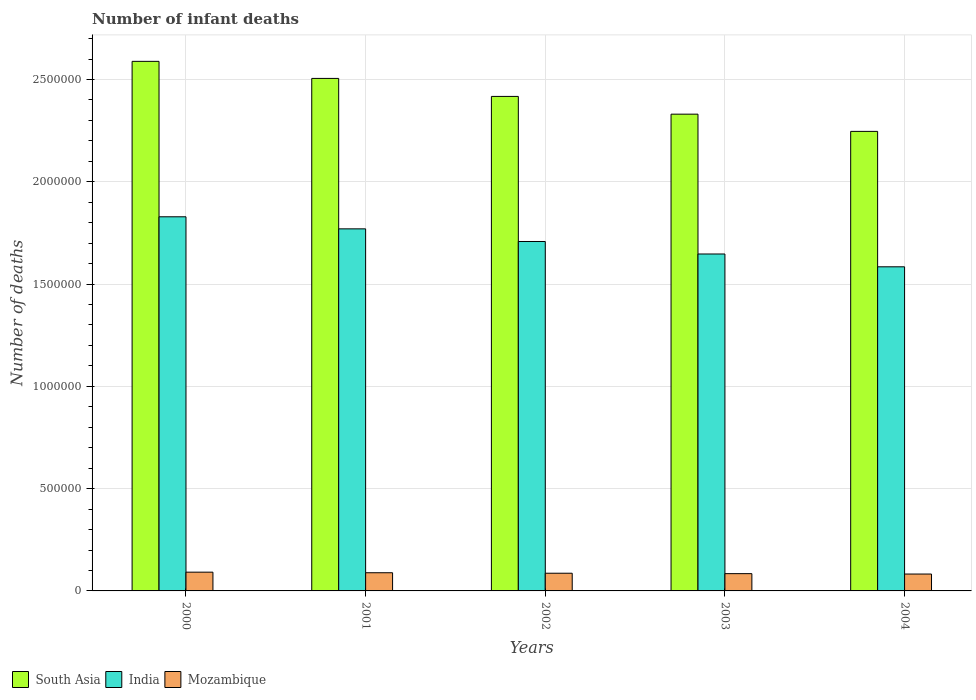How many different coloured bars are there?
Your answer should be compact. 3. How many groups of bars are there?
Keep it short and to the point. 5. Are the number of bars per tick equal to the number of legend labels?
Your answer should be very brief. Yes. Are the number of bars on each tick of the X-axis equal?
Ensure brevity in your answer.  Yes. What is the label of the 5th group of bars from the left?
Your answer should be compact. 2004. What is the number of infant deaths in Mozambique in 2004?
Ensure brevity in your answer.  8.25e+04. Across all years, what is the maximum number of infant deaths in Mozambique?
Keep it short and to the point. 9.17e+04. Across all years, what is the minimum number of infant deaths in India?
Provide a short and direct response. 1.58e+06. In which year was the number of infant deaths in South Asia maximum?
Your response must be concise. 2000. In which year was the number of infant deaths in India minimum?
Provide a succinct answer. 2004. What is the total number of infant deaths in Mozambique in the graph?
Offer a very short reply. 4.34e+05. What is the difference between the number of infant deaths in India in 2000 and that in 2003?
Make the answer very short. 1.82e+05. What is the difference between the number of infant deaths in South Asia in 2000 and the number of infant deaths in India in 2003?
Offer a terse response. 9.42e+05. What is the average number of infant deaths in Mozambique per year?
Offer a very short reply. 8.68e+04. In the year 2000, what is the difference between the number of infant deaths in Mozambique and number of infant deaths in South Asia?
Provide a short and direct response. -2.50e+06. What is the ratio of the number of infant deaths in Mozambique in 2000 to that in 2002?
Provide a succinct answer. 1.06. What is the difference between the highest and the second highest number of infant deaths in Mozambique?
Make the answer very short. 2783. What is the difference between the highest and the lowest number of infant deaths in India?
Provide a short and direct response. 2.44e+05. In how many years, is the number of infant deaths in Mozambique greater than the average number of infant deaths in Mozambique taken over all years?
Provide a short and direct response. 2. What does the 1st bar from the right in 2003 represents?
Keep it short and to the point. Mozambique. Is it the case that in every year, the sum of the number of infant deaths in Mozambique and number of infant deaths in South Asia is greater than the number of infant deaths in India?
Provide a short and direct response. Yes. How many years are there in the graph?
Ensure brevity in your answer.  5. What is the difference between two consecutive major ticks on the Y-axis?
Your response must be concise. 5.00e+05. Does the graph contain grids?
Offer a very short reply. Yes. Where does the legend appear in the graph?
Your answer should be very brief. Bottom left. How many legend labels are there?
Make the answer very short. 3. How are the legend labels stacked?
Your answer should be compact. Horizontal. What is the title of the graph?
Offer a terse response. Number of infant deaths. Does "Dominican Republic" appear as one of the legend labels in the graph?
Ensure brevity in your answer.  No. What is the label or title of the X-axis?
Offer a very short reply. Years. What is the label or title of the Y-axis?
Keep it short and to the point. Number of deaths. What is the Number of deaths of South Asia in 2000?
Provide a short and direct response. 2.59e+06. What is the Number of deaths of India in 2000?
Your response must be concise. 1.83e+06. What is the Number of deaths of Mozambique in 2000?
Your answer should be very brief. 9.17e+04. What is the Number of deaths of South Asia in 2001?
Your answer should be very brief. 2.51e+06. What is the Number of deaths in India in 2001?
Keep it short and to the point. 1.77e+06. What is the Number of deaths of Mozambique in 2001?
Keep it short and to the point. 8.89e+04. What is the Number of deaths in South Asia in 2002?
Keep it short and to the point. 2.42e+06. What is the Number of deaths in India in 2002?
Offer a very short reply. 1.71e+06. What is the Number of deaths in Mozambique in 2002?
Your response must be concise. 8.65e+04. What is the Number of deaths in South Asia in 2003?
Ensure brevity in your answer.  2.33e+06. What is the Number of deaths in India in 2003?
Make the answer very short. 1.65e+06. What is the Number of deaths of Mozambique in 2003?
Keep it short and to the point. 8.44e+04. What is the Number of deaths in South Asia in 2004?
Provide a short and direct response. 2.25e+06. What is the Number of deaths in India in 2004?
Your answer should be compact. 1.58e+06. What is the Number of deaths of Mozambique in 2004?
Your answer should be very brief. 8.25e+04. Across all years, what is the maximum Number of deaths in South Asia?
Ensure brevity in your answer.  2.59e+06. Across all years, what is the maximum Number of deaths of India?
Ensure brevity in your answer.  1.83e+06. Across all years, what is the maximum Number of deaths in Mozambique?
Your answer should be compact. 9.17e+04. Across all years, what is the minimum Number of deaths in South Asia?
Offer a very short reply. 2.25e+06. Across all years, what is the minimum Number of deaths of India?
Provide a short and direct response. 1.58e+06. Across all years, what is the minimum Number of deaths in Mozambique?
Ensure brevity in your answer.  8.25e+04. What is the total Number of deaths of South Asia in the graph?
Keep it short and to the point. 1.21e+07. What is the total Number of deaths of India in the graph?
Keep it short and to the point. 8.54e+06. What is the total Number of deaths of Mozambique in the graph?
Your answer should be very brief. 4.34e+05. What is the difference between the Number of deaths in South Asia in 2000 and that in 2001?
Make the answer very short. 8.34e+04. What is the difference between the Number of deaths of India in 2000 and that in 2001?
Keep it short and to the point. 5.90e+04. What is the difference between the Number of deaths of Mozambique in 2000 and that in 2001?
Give a very brief answer. 2783. What is the difference between the Number of deaths of South Asia in 2000 and that in 2002?
Your response must be concise. 1.71e+05. What is the difference between the Number of deaths in India in 2000 and that in 2002?
Ensure brevity in your answer.  1.21e+05. What is the difference between the Number of deaths in Mozambique in 2000 and that in 2002?
Offer a terse response. 5152. What is the difference between the Number of deaths in South Asia in 2000 and that in 2003?
Your response must be concise. 2.58e+05. What is the difference between the Number of deaths of India in 2000 and that in 2003?
Keep it short and to the point. 1.82e+05. What is the difference between the Number of deaths of Mozambique in 2000 and that in 2003?
Make the answer very short. 7238. What is the difference between the Number of deaths of South Asia in 2000 and that in 2004?
Provide a succinct answer. 3.42e+05. What is the difference between the Number of deaths in India in 2000 and that in 2004?
Your answer should be compact. 2.44e+05. What is the difference between the Number of deaths of Mozambique in 2000 and that in 2004?
Give a very brief answer. 9178. What is the difference between the Number of deaths of South Asia in 2001 and that in 2002?
Provide a short and direct response. 8.80e+04. What is the difference between the Number of deaths of India in 2001 and that in 2002?
Provide a short and direct response. 6.18e+04. What is the difference between the Number of deaths of Mozambique in 2001 and that in 2002?
Offer a very short reply. 2369. What is the difference between the Number of deaths in South Asia in 2001 and that in 2003?
Make the answer very short. 1.75e+05. What is the difference between the Number of deaths in India in 2001 and that in 2003?
Offer a very short reply. 1.23e+05. What is the difference between the Number of deaths in Mozambique in 2001 and that in 2003?
Provide a short and direct response. 4455. What is the difference between the Number of deaths of South Asia in 2001 and that in 2004?
Your answer should be very brief. 2.59e+05. What is the difference between the Number of deaths of India in 2001 and that in 2004?
Your response must be concise. 1.86e+05. What is the difference between the Number of deaths in Mozambique in 2001 and that in 2004?
Offer a terse response. 6395. What is the difference between the Number of deaths of South Asia in 2002 and that in 2003?
Make the answer very short. 8.68e+04. What is the difference between the Number of deaths of India in 2002 and that in 2003?
Make the answer very short. 6.11e+04. What is the difference between the Number of deaths in Mozambique in 2002 and that in 2003?
Make the answer very short. 2086. What is the difference between the Number of deaths of South Asia in 2002 and that in 2004?
Make the answer very short. 1.71e+05. What is the difference between the Number of deaths of India in 2002 and that in 2004?
Offer a very short reply. 1.24e+05. What is the difference between the Number of deaths of Mozambique in 2002 and that in 2004?
Offer a terse response. 4026. What is the difference between the Number of deaths in South Asia in 2003 and that in 2004?
Your response must be concise. 8.42e+04. What is the difference between the Number of deaths of India in 2003 and that in 2004?
Keep it short and to the point. 6.26e+04. What is the difference between the Number of deaths in Mozambique in 2003 and that in 2004?
Offer a terse response. 1940. What is the difference between the Number of deaths of South Asia in 2000 and the Number of deaths of India in 2001?
Offer a very short reply. 8.19e+05. What is the difference between the Number of deaths of South Asia in 2000 and the Number of deaths of Mozambique in 2001?
Offer a very short reply. 2.50e+06. What is the difference between the Number of deaths of India in 2000 and the Number of deaths of Mozambique in 2001?
Make the answer very short. 1.74e+06. What is the difference between the Number of deaths in South Asia in 2000 and the Number of deaths in India in 2002?
Offer a terse response. 8.81e+05. What is the difference between the Number of deaths of South Asia in 2000 and the Number of deaths of Mozambique in 2002?
Your answer should be very brief. 2.50e+06. What is the difference between the Number of deaths in India in 2000 and the Number of deaths in Mozambique in 2002?
Offer a very short reply. 1.74e+06. What is the difference between the Number of deaths in South Asia in 2000 and the Number of deaths in India in 2003?
Your answer should be very brief. 9.42e+05. What is the difference between the Number of deaths of South Asia in 2000 and the Number of deaths of Mozambique in 2003?
Your answer should be very brief. 2.50e+06. What is the difference between the Number of deaths of India in 2000 and the Number of deaths of Mozambique in 2003?
Provide a succinct answer. 1.74e+06. What is the difference between the Number of deaths in South Asia in 2000 and the Number of deaths in India in 2004?
Ensure brevity in your answer.  1.00e+06. What is the difference between the Number of deaths in South Asia in 2000 and the Number of deaths in Mozambique in 2004?
Keep it short and to the point. 2.51e+06. What is the difference between the Number of deaths in India in 2000 and the Number of deaths in Mozambique in 2004?
Your answer should be compact. 1.75e+06. What is the difference between the Number of deaths in South Asia in 2001 and the Number of deaths in India in 2002?
Give a very brief answer. 7.97e+05. What is the difference between the Number of deaths of South Asia in 2001 and the Number of deaths of Mozambique in 2002?
Keep it short and to the point. 2.42e+06. What is the difference between the Number of deaths in India in 2001 and the Number of deaths in Mozambique in 2002?
Ensure brevity in your answer.  1.68e+06. What is the difference between the Number of deaths in South Asia in 2001 and the Number of deaths in India in 2003?
Give a very brief answer. 8.58e+05. What is the difference between the Number of deaths of South Asia in 2001 and the Number of deaths of Mozambique in 2003?
Offer a terse response. 2.42e+06. What is the difference between the Number of deaths in India in 2001 and the Number of deaths in Mozambique in 2003?
Keep it short and to the point. 1.69e+06. What is the difference between the Number of deaths in South Asia in 2001 and the Number of deaths in India in 2004?
Make the answer very short. 9.21e+05. What is the difference between the Number of deaths in South Asia in 2001 and the Number of deaths in Mozambique in 2004?
Your answer should be compact. 2.42e+06. What is the difference between the Number of deaths of India in 2001 and the Number of deaths of Mozambique in 2004?
Provide a succinct answer. 1.69e+06. What is the difference between the Number of deaths of South Asia in 2002 and the Number of deaths of India in 2003?
Offer a very short reply. 7.70e+05. What is the difference between the Number of deaths in South Asia in 2002 and the Number of deaths in Mozambique in 2003?
Make the answer very short. 2.33e+06. What is the difference between the Number of deaths in India in 2002 and the Number of deaths in Mozambique in 2003?
Your answer should be very brief. 1.62e+06. What is the difference between the Number of deaths in South Asia in 2002 and the Number of deaths in India in 2004?
Offer a terse response. 8.33e+05. What is the difference between the Number of deaths in South Asia in 2002 and the Number of deaths in Mozambique in 2004?
Your answer should be very brief. 2.33e+06. What is the difference between the Number of deaths of India in 2002 and the Number of deaths of Mozambique in 2004?
Provide a succinct answer. 1.63e+06. What is the difference between the Number of deaths of South Asia in 2003 and the Number of deaths of India in 2004?
Ensure brevity in your answer.  7.46e+05. What is the difference between the Number of deaths in South Asia in 2003 and the Number of deaths in Mozambique in 2004?
Your answer should be very brief. 2.25e+06. What is the difference between the Number of deaths of India in 2003 and the Number of deaths of Mozambique in 2004?
Ensure brevity in your answer.  1.56e+06. What is the average Number of deaths in South Asia per year?
Offer a terse response. 2.42e+06. What is the average Number of deaths in India per year?
Make the answer very short. 1.71e+06. What is the average Number of deaths in Mozambique per year?
Your answer should be very brief. 8.68e+04. In the year 2000, what is the difference between the Number of deaths of South Asia and Number of deaths of India?
Your answer should be compact. 7.60e+05. In the year 2000, what is the difference between the Number of deaths of South Asia and Number of deaths of Mozambique?
Give a very brief answer. 2.50e+06. In the year 2000, what is the difference between the Number of deaths in India and Number of deaths in Mozambique?
Your response must be concise. 1.74e+06. In the year 2001, what is the difference between the Number of deaths of South Asia and Number of deaths of India?
Make the answer very short. 7.35e+05. In the year 2001, what is the difference between the Number of deaths in South Asia and Number of deaths in Mozambique?
Make the answer very short. 2.42e+06. In the year 2001, what is the difference between the Number of deaths in India and Number of deaths in Mozambique?
Make the answer very short. 1.68e+06. In the year 2002, what is the difference between the Number of deaths in South Asia and Number of deaths in India?
Your answer should be very brief. 7.09e+05. In the year 2002, what is the difference between the Number of deaths of South Asia and Number of deaths of Mozambique?
Make the answer very short. 2.33e+06. In the year 2002, what is the difference between the Number of deaths in India and Number of deaths in Mozambique?
Provide a short and direct response. 1.62e+06. In the year 2003, what is the difference between the Number of deaths in South Asia and Number of deaths in India?
Offer a very short reply. 6.84e+05. In the year 2003, what is the difference between the Number of deaths of South Asia and Number of deaths of Mozambique?
Give a very brief answer. 2.25e+06. In the year 2003, what is the difference between the Number of deaths in India and Number of deaths in Mozambique?
Offer a terse response. 1.56e+06. In the year 2004, what is the difference between the Number of deaths in South Asia and Number of deaths in India?
Your answer should be very brief. 6.62e+05. In the year 2004, what is the difference between the Number of deaths in South Asia and Number of deaths in Mozambique?
Provide a succinct answer. 2.16e+06. In the year 2004, what is the difference between the Number of deaths in India and Number of deaths in Mozambique?
Offer a terse response. 1.50e+06. What is the ratio of the Number of deaths of India in 2000 to that in 2001?
Give a very brief answer. 1.03. What is the ratio of the Number of deaths of Mozambique in 2000 to that in 2001?
Your answer should be very brief. 1.03. What is the ratio of the Number of deaths of South Asia in 2000 to that in 2002?
Your answer should be compact. 1.07. What is the ratio of the Number of deaths in India in 2000 to that in 2002?
Offer a terse response. 1.07. What is the ratio of the Number of deaths in Mozambique in 2000 to that in 2002?
Keep it short and to the point. 1.06. What is the ratio of the Number of deaths of South Asia in 2000 to that in 2003?
Provide a succinct answer. 1.11. What is the ratio of the Number of deaths of India in 2000 to that in 2003?
Offer a terse response. 1.11. What is the ratio of the Number of deaths of Mozambique in 2000 to that in 2003?
Offer a very short reply. 1.09. What is the ratio of the Number of deaths in South Asia in 2000 to that in 2004?
Keep it short and to the point. 1.15. What is the ratio of the Number of deaths in India in 2000 to that in 2004?
Provide a short and direct response. 1.15. What is the ratio of the Number of deaths of Mozambique in 2000 to that in 2004?
Provide a succinct answer. 1.11. What is the ratio of the Number of deaths of South Asia in 2001 to that in 2002?
Offer a very short reply. 1.04. What is the ratio of the Number of deaths in India in 2001 to that in 2002?
Keep it short and to the point. 1.04. What is the ratio of the Number of deaths in Mozambique in 2001 to that in 2002?
Your answer should be very brief. 1.03. What is the ratio of the Number of deaths in South Asia in 2001 to that in 2003?
Give a very brief answer. 1.07. What is the ratio of the Number of deaths of India in 2001 to that in 2003?
Your answer should be compact. 1.07. What is the ratio of the Number of deaths of Mozambique in 2001 to that in 2003?
Ensure brevity in your answer.  1.05. What is the ratio of the Number of deaths of South Asia in 2001 to that in 2004?
Provide a succinct answer. 1.12. What is the ratio of the Number of deaths of India in 2001 to that in 2004?
Provide a short and direct response. 1.12. What is the ratio of the Number of deaths of Mozambique in 2001 to that in 2004?
Offer a very short reply. 1.08. What is the ratio of the Number of deaths of South Asia in 2002 to that in 2003?
Provide a short and direct response. 1.04. What is the ratio of the Number of deaths of India in 2002 to that in 2003?
Keep it short and to the point. 1.04. What is the ratio of the Number of deaths of Mozambique in 2002 to that in 2003?
Keep it short and to the point. 1.02. What is the ratio of the Number of deaths of South Asia in 2002 to that in 2004?
Keep it short and to the point. 1.08. What is the ratio of the Number of deaths of India in 2002 to that in 2004?
Your answer should be very brief. 1.08. What is the ratio of the Number of deaths in Mozambique in 2002 to that in 2004?
Keep it short and to the point. 1.05. What is the ratio of the Number of deaths of South Asia in 2003 to that in 2004?
Your answer should be very brief. 1.04. What is the ratio of the Number of deaths in India in 2003 to that in 2004?
Your response must be concise. 1.04. What is the ratio of the Number of deaths of Mozambique in 2003 to that in 2004?
Make the answer very short. 1.02. What is the difference between the highest and the second highest Number of deaths of South Asia?
Your answer should be very brief. 8.34e+04. What is the difference between the highest and the second highest Number of deaths of India?
Give a very brief answer. 5.90e+04. What is the difference between the highest and the second highest Number of deaths in Mozambique?
Offer a very short reply. 2783. What is the difference between the highest and the lowest Number of deaths of South Asia?
Your answer should be compact. 3.42e+05. What is the difference between the highest and the lowest Number of deaths in India?
Your answer should be compact. 2.44e+05. What is the difference between the highest and the lowest Number of deaths in Mozambique?
Offer a terse response. 9178. 